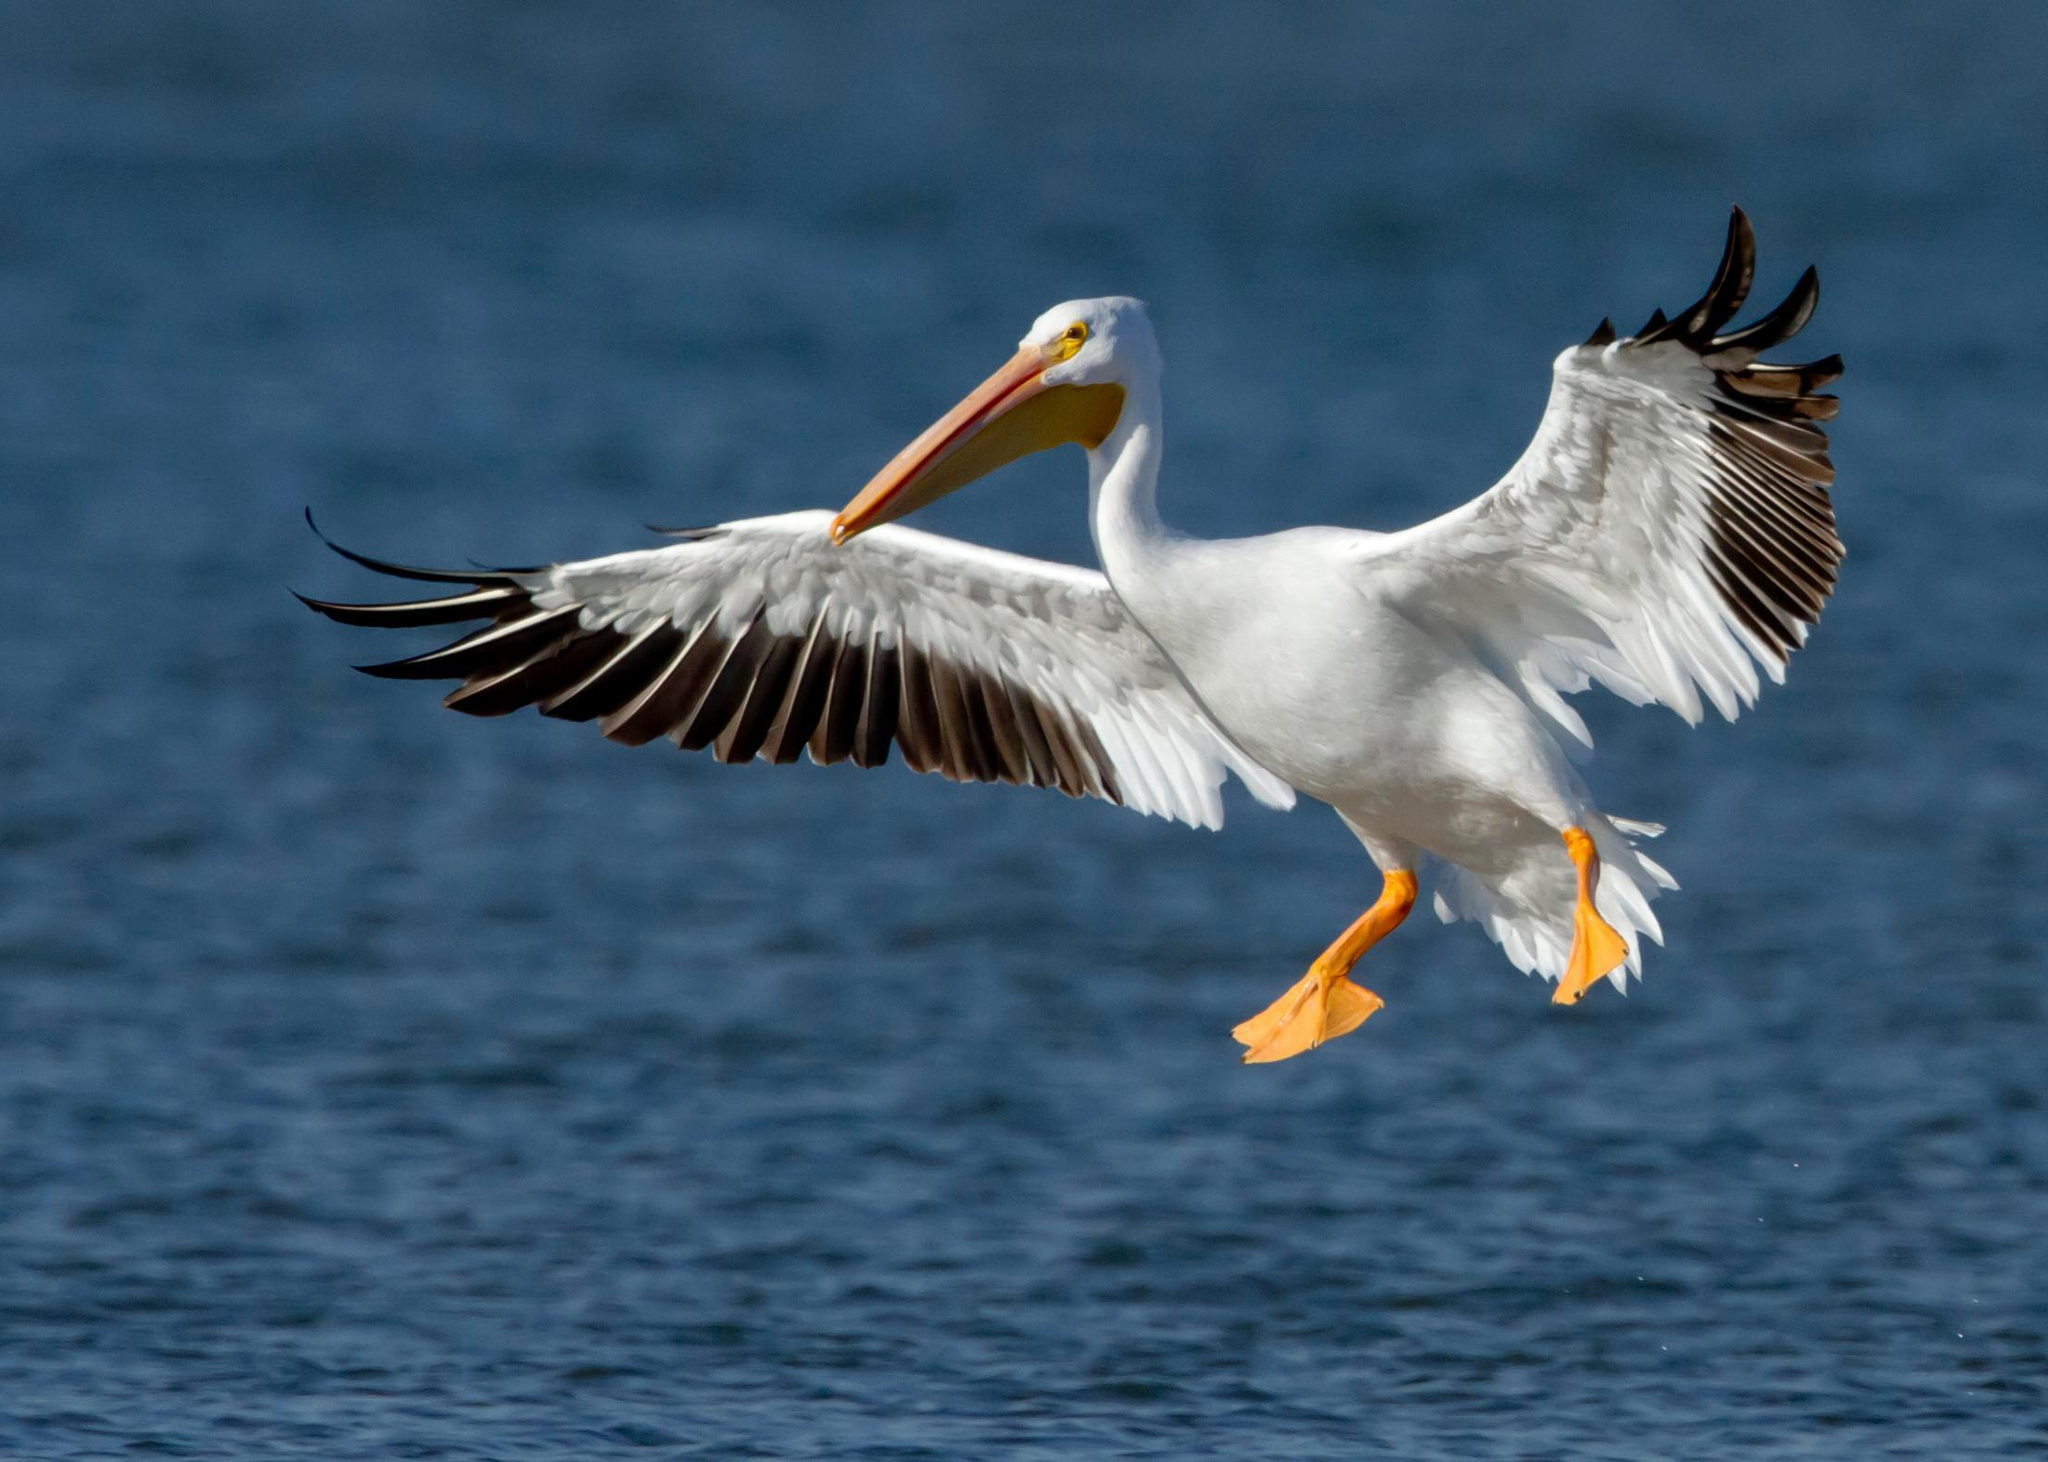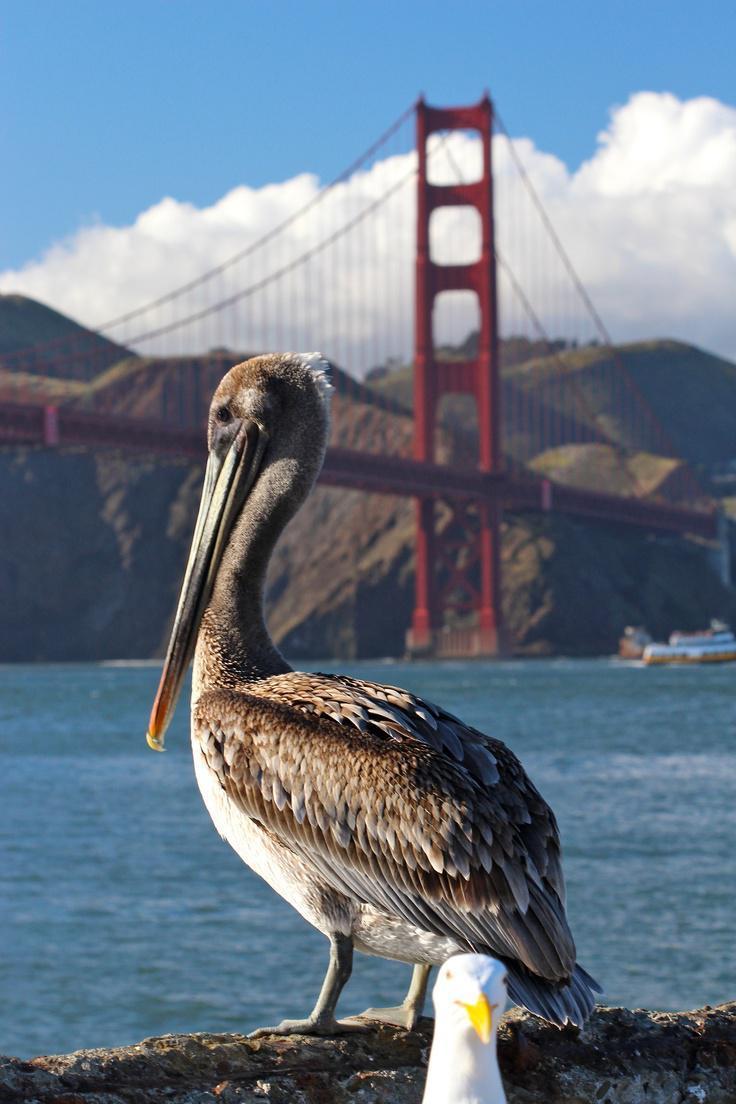The first image is the image on the left, the second image is the image on the right. Analyze the images presented: Is the assertion "In one of the images, there is a pelican in flight" valid? Answer yes or no. Yes. 